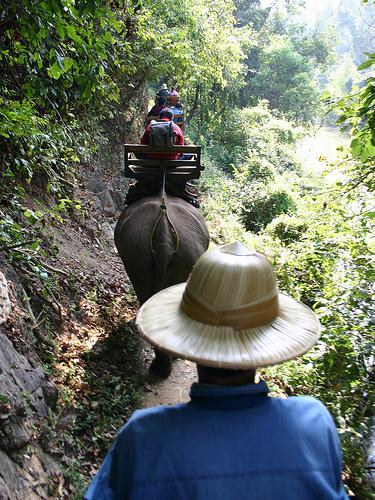Question: where is the picture taken?
Choices:
A. In a van.
B. Out a door.
C. On a safari.
D. By a mailbox.
Answer with the letter. Answer: C Question: what is bright?
Choices:
A. The sun.
B. The light.
C. The moon.
D. The stars.
Answer with the letter. Answer: A Question: who is wearing a saddle?
Choices:
A. The camel.
B. Giraff.
C. The elephant.
D. Horse.
Answer with the letter. Answer: C 